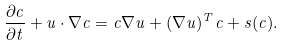Convert formula to latex. <formula><loc_0><loc_0><loc_500><loc_500>\frac { \partial c } { \partial t } + u \cdot \nabla c = c \nabla u + ( \nabla u ) ^ { T } c + s ( c ) .</formula> 